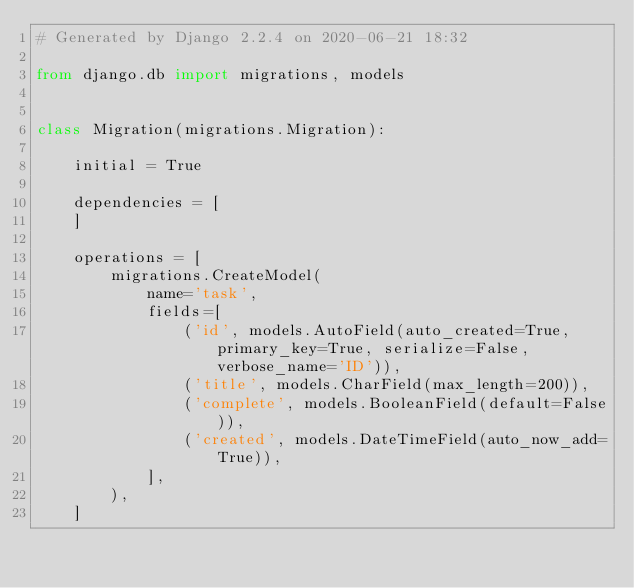<code> <loc_0><loc_0><loc_500><loc_500><_Python_># Generated by Django 2.2.4 on 2020-06-21 18:32

from django.db import migrations, models


class Migration(migrations.Migration):

    initial = True

    dependencies = [
    ]

    operations = [
        migrations.CreateModel(
            name='task',
            fields=[
                ('id', models.AutoField(auto_created=True, primary_key=True, serialize=False, verbose_name='ID')),
                ('title', models.CharField(max_length=200)),
                ('complete', models.BooleanField(default=False)),
                ('created', models.DateTimeField(auto_now_add=True)),
            ],
        ),
    ]
</code> 